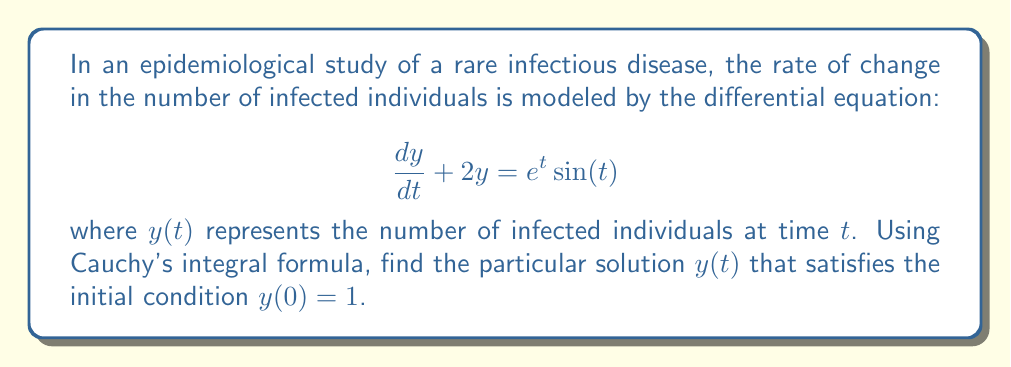Teach me how to tackle this problem. To solve this differential equation using Cauchy's integral formula, we'll follow these steps:

1) First, we need to rewrite the equation in the standard form:
   $$\frac{dy}{dt} + 2y = e^t\sin(t)$$

2) The general solution to this equation can be written as:
   $$y(t) = e^{-2t}\left(C + \int_0^t e^{2s}e^s\sin(s)ds\right)$$
   where $C$ is a constant determined by the initial condition.

3) To apply Cauchy's integral formula, we need to express the integrand in terms of a complex function. Let's define:
   $$f(z) = e^{(2+1)z}\sin(z) = e^{3z}\sin(z)$$

4) Now, we can use Cauchy's integral formula:
   $$\int_0^t e^{2s}e^s\sin(s)ds = \frac{1}{2\pi i}\oint_C \frac{f(z)}{z-t}dz$$
   where $C$ is a positively oriented contour enclosing $t$ but not enclosing any singularities of $f(z)$.

5) The function $f(z) = e^{3z}\sin(z)$ is entire, so we can choose any contour. Let's use a circular contour centered at $t$ with radius $R$.

6) Evaluating this contour integral:
   $$\frac{1}{2\pi i}\oint_C \frac{f(z)}{z-t}dz = f(t) = e^{3t}\sin(t)$$

7) Substituting this back into our general solution:
   $$y(t) = e^{-2t}(C + e^{3t}\sin(t))$$

8) To find $C$, we use the initial condition $y(0) = 1$:
   $$1 = y(0) = e^0(C + e^0\sin(0)) = C$$

9) Therefore, our particular solution is:
   $$y(t) = e^{-2t}(1 + e^{3t}\sin(t))$$

10) Simplifying:
    $$y(t) = e^{-2t} + e^t\sin(t)$$
Answer: $y(t) = e^{-2t} + e^t\sin(t)$ 